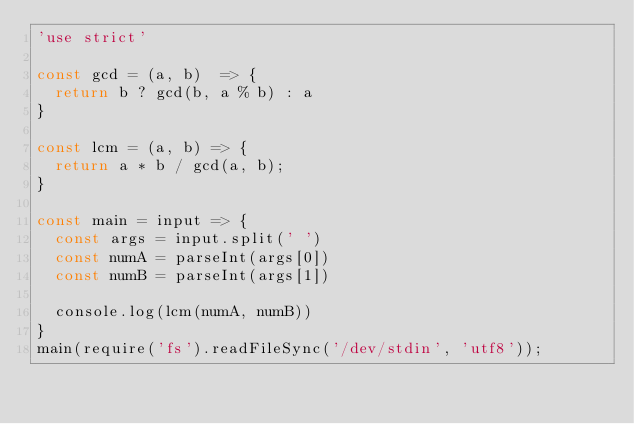<code> <loc_0><loc_0><loc_500><loc_500><_JavaScript_>'use strict'

const gcd = (a, b)  => {
  return b ? gcd(b, a % b) : a
}

const lcm = (a, b) => {
  return a * b / gcd(a, b);
}

const main = input => {
  const args = input.split(' ')
  const numA = parseInt(args[0])
  const numB = parseInt(args[1])
  
  console.log(lcm(numA, numB)) 
}
main(require('fs').readFileSync('/dev/stdin', 'utf8'));</code> 